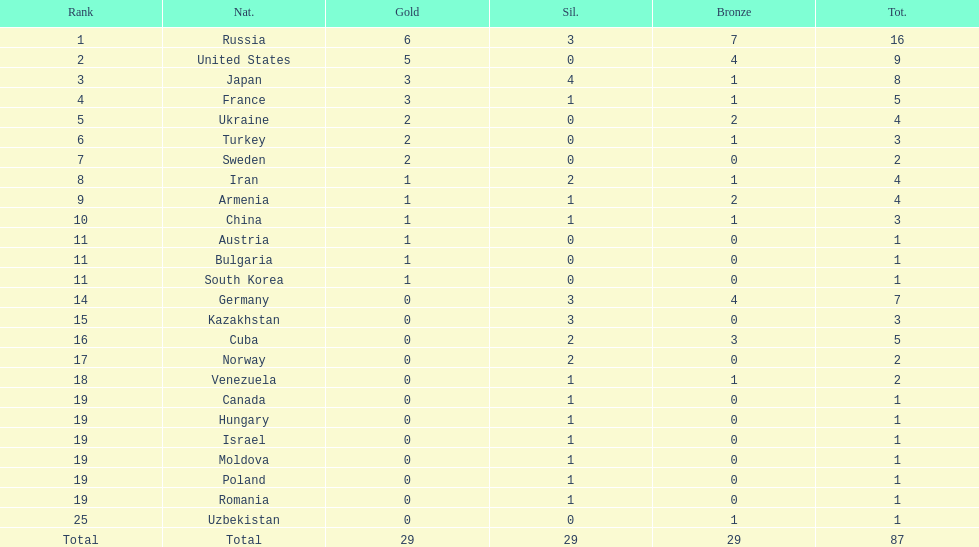How many combined gold medals did japan and france win? 6. 